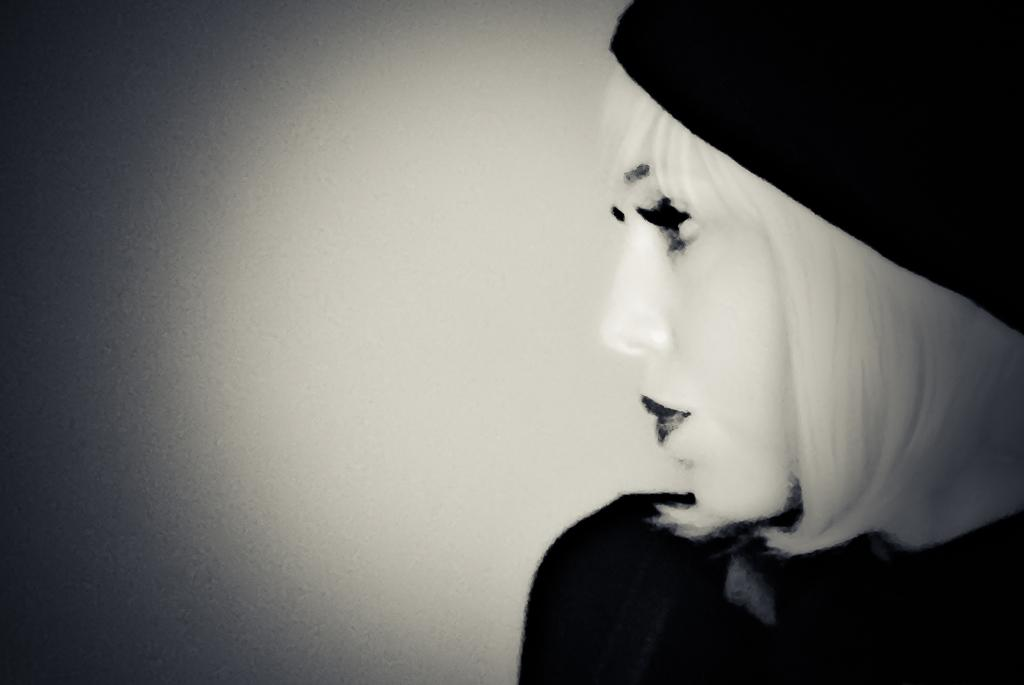What is the color scheme of the image? The image is black and white. Can you describe the person in the image? There is a woman in the image. What is the woman wearing on her head? The woman is wearing a cap. Can you tell me how many goats are present in the image? There are no goats present in the image; it features a woman wearing a cap. What type of cent is depicted on the woman's cap? There is no cent depicted on the woman's cap; it is simply a black and white image of a woman wearing a cap. 